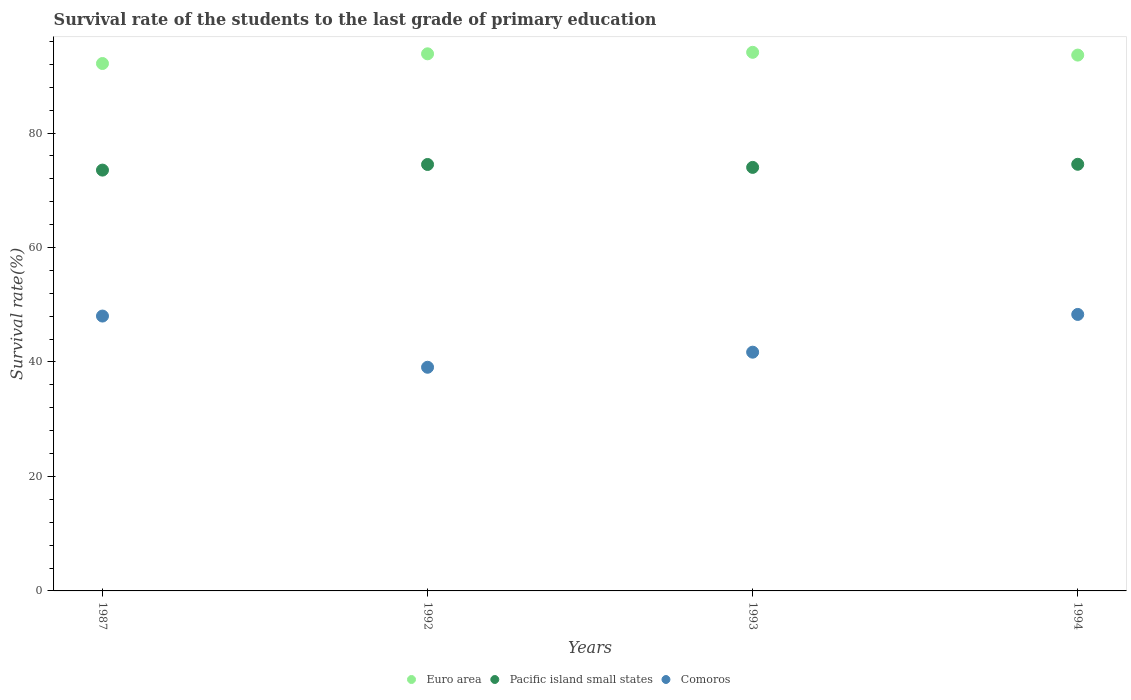How many different coloured dotlines are there?
Your answer should be very brief. 3. Is the number of dotlines equal to the number of legend labels?
Provide a short and direct response. Yes. What is the survival rate of the students in Pacific island small states in 1994?
Give a very brief answer. 74.54. Across all years, what is the maximum survival rate of the students in Pacific island small states?
Offer a very short reply. 74.54. Across all years, what is the minimum survival rate of the students in Euro area?
Offer a terse response. 92.15. In which year was the survival rate of the students in Pacific island small states maximum?
Your response must be concise. 1994. In which year was the survival rate of the students in Pacific island small states minimum?
Your answer should be compact. 1987. What is the total survival rate of the students in Euro area in the graph?
Offer a terse response. 373.71. What is the difference between the survival rate of the students in Pacific island small states in 1993 and that in 1994?
Offer a very short reply. -0.54. What is the difference between the survival rate of the students in Pacific island small states in 1994 and the survival rate of the students in Euro area in 1987?
Offer a terse response. -17.61. What is the average survival rate of the students in Comoros per year?
Offer a terse response. 44.28. In the year 1994, what is the difference between the survival rate of the students in Pacific island small states and survival rate of the students in Euro area?
Make the answer very short. -19.08. What is the ratio of the survival rate of the students in Comoros in 1987 to that in 1994?
Make the answer very short. 0.99. Is the survival rate of the students in Euro area in 1992 less than that in 1993?
Your response must be concise. Yes. Is the difference between the survival rate of the students in Pacific island small states in 1987 and 1994 greater than the difference between the survival rate of the students in Euro area in 1987 and 1994?
Your answer should be very brief. Yes. What is the difference between the highest and the second highest survival rate of the students in Euro area?
Make the answer very short. 0.26. What is the difference between the highest and the lowest survival rate of the students in Pacific island small states?
Provide a succinct answer. 1.02. In how many years, is the survival rate of the students in Euro area greater than the average survival rate of the students in Euro area taken over all years?
Offer a terse response. 3. Is the sum of the survival rate of the students in Euro area in 1987 and 1994 greater than the maximum survival rate of the students in Comoros across all years?
Your answer should be compact. Yes. Is it the case that in every year, the sum of the survival rate of the students in Comoros and survival rate of the students in Euro area  is greater than the survival rate of the students in Pacific island small states?
Offer a terse response. Yes. Is the survival rate of the students in Comoros strictly less than the survival rate of the students in Pacific island small states over the years?
Your answer should be very brief. Yes. How many dotlines are there?
Your response must be concise. 3. What is the difference between two consecutive major ticks on the Y-axis?
Your response must be concise. 20. Are the values on the major ticks of Y-axis written in scientific E-notation?
Offer a very short reply. No. Does the graph contain any zero values?
Make the answer very short. No. How many legend labels are there?
Your response must be concise. 3. What is the title of the graph?
Offer a terse response. Survival rate of the students to the last grade of primary education. What is the label or title of the Y-axis?
Provide a succinct answer. Survival rate(%). What is the Survival rate(%) in Euro area in 1987?
Keep it short and to the point. 92.15. What is the Survival rate(%) of Pacific island small states in 1987?
Your response must be concise. 73.52. What is the Survival rate(%) in Comoros in 1987?
Provide a short and direct response. 48.02. What is the Survival rate(%) in Euro area in 1992?
Your response must be concise. 93.84. What is the Survival rate(%) of Pacific island small states in 1992?
Offer a very short reply. 74.51. What is the Survival rate(%) in Comoros in 1992?
Offer a very short reply. 39.08. What is the Survival rate(%) in Euro area in 1993?
Your answer should be compact. 94.1. What is the Survival rate(%) of Pacific island small states in 1993?
Offer a very short reply. 74. What is the Survival rate(%) of Comoros in 1993?
Ensure brevity in your answer.  41.71. What is the Survival rate(%) of Euro area in 1994?
Your answer should be compact. 93.62. What is the Survival rate(%) of Pacific island small states in 1994?
Provide a short and direct response. 74.54. What is the Survival rate(%) of Comoros in 1994?
Ensure brevity in your answer.  48.31. Across all years, what is the maximum Survival rate(%) in Euro area?
Keep it short and to the point. 94.1. Across all years, what is the maximum Survival rate(%) of Pacific island small states?
Your answer should be compact. 74.54. Across all years, what is the maximum Survival rate(%) in Comoros?
Offer a terse response. 48.31. Across all years, what is the minimum Survival rate(%) of Euro area?
Give a very brief answer. 92.15. Across all years, what is the minimum Survival rate(%) in Pacific island small states?
Offer a terse response. 73.52. Across all years, what is the minimum Survival rate(%) in Comoros?
Offer a very short reply. 39.08. What is the total Survival rate(%) in Euro area in the graph?
Offer a terse response. 373.71. What is the total Survival rate(%) in Pacific island small states in the graph?
Your response must be concise. 296.57. What is the total Survival rate(%) of Comoros in the graph?
Provide a short and direct response. 177.12. What is the difference between the Survival rate(%) of Euro area in 1987 and that in 1992?
Offer a terse response. -1.69. What is the difference between the Survival rate(%) of Pacific island small states in 1987 and that in 1992?
Your answer should be very brief. -0.98. What is the difference between the Survival rate(%) of Comoros in 1987 and that in 1992?
Offer a terse response. 8.95. What is the difference between the Survival rate(%) of Euro area in 1987 and that in 1993?
Give a very brief answer. -1.96. What is the difference between the Survival rate(%) of Pacific island small states in 1987 and that in 1993?
Provide a succinct answer. -0.47. What is the difference between the Survival rate(%) in Comoros in 1987 and that in 1993?
Provide a succinct answer. 6.31. What is the difference between the Survival rate(%) of Euro area in 1987 and that in 1994?
Offer a terse response. -1.47. What is the difference between the Survival rate(%) of Pacific island small states in 1987 and that in 1994?
Give a very brief answer. -1.02. What is the difference between the Survival rate(%) of Comoros in 1987 and that in 1994?
Your answer should be very brief. -0.28. What is the difference between the Survival rate(%) in Euro area in 1992 and that in 1993?
Give a very brief answer. -0.26. What is the difference between the Survival rate(%) in Pacific island small states in 1992 and that in 1993?
Provide a succinct answer. 0.51. What is the difference between the Survival rate(%) of Comoros in 1992 and that in 1993?
Offer a terse response. -2.64. What is the difference between the Survival rate(%) of Euro area in 1992 and that in 1994?
Make the answer very short. 0.22. What is the difference between the Survival rate(%) in Pacific island small states in 1992 and that in 1994?
Your answer should be compact. -0.03. What is the difference between the Survival rate(%) in Comoros in 1992 and that in 1994?
Your answer should be very brief. -9.23. What is the difference between the Survival rate(%) in Euro area in 1993 and that in 1994?
Provide a short and direct response. 0.48. What is the difference between the Survival rate(%) in Pacific island small states in 1993 and that in 1994?
Your response must be concise. -0.54. What is the difference between the Survival rate(%) of Comoros in 1993 and that in 1994?
Ensure brevity in your answer.  -6.59. What is the difference between the Survival rate(%) of Euro area in 1987 and the Survival rate(%) of Pacific island small states in 1992?
Offer a very short reply. 17.64. What is the difference between the Survival rate(%) of Euro area in 1987 and the Survival rate(%) of Comoros in 1992?
Make the answer very short. 53.07. What is the difference between the Survival rate(%) of Pacific island small states in 1987 and the Survival rate(%) of Comoros in 1992?
Give a very brief answer. 34.45. What is the difference between the Survival rate(%) of Euro area in 1987 and the Survival rate(%) of Pacific island small states in 1993?
Ensure brevity in your answer.  18.15. What is the difference between the Survival rate(%) of Euro area in 1987 and the Survival rate(%) of Comoros in 1993?
Your answer should be compact. 50.44. What is the difference between the Survival rate(%) in Pacific island small states in 1987 and the Survival rate(%) in Comoros in 1993?
Provide a short and direct response. 31.81. What is the difference between the Survival rate(%) of Euro area in 1987 and the Survival rate(%) of Pacific island small states in 1994?
Offer a terse response. 17.61. What is the difference between the Survival rate(%) of Euro area in 1987 and the Survival rate(%) of Comoros in 1994?
Keep it short and to the point. 43.84. What is the difference between the Survival rate(%) of Pacific island small states in 1987 and the Survival rate(%) of Comoros in 1994?
Provide a short and direct response. 25.22. What is the difference between the Survival rate(%) of Euro area in 1992 and the Survival rate(%) of Pacific island small states in 1993?
Offer a terse response. 19.84. What is the difference between the Survival rate(%) of Euro area in 1992 and the Survival rate(%) of Comoros in 1993?
Your response must be concise. 52.13. What is the difference between the Survival rate(%) of Pacific island small states in 1992 and the Survival rate(%) of Comoros in 1993?
Your response must be concise. 32.79. What is the difference between the Survival rate(%) in Euro area in 1992 and the Survival rate(%) in Pacific island small states in 1994?
Your answer should be very brief. 19.3. What is the difference between the Survival rate(%) of Euro area in 1992 and the Survival rate(%) of Comoros in 1994?
Your answer should be very brief. 45.53. What is the difference between the Survival rate(%) in Pacific island small states in 1992 and the Survival rate(%) in Comoros in 1994?
Keep it short and to the point. 26.2. What is the difference between the Survival rate(%) in Euro area in 1993 and the Survival rate(%) in Pacific island small states in 1994?
Your answer should be compact. 19.56. What is the difference between the Survival rate(%) in Euro area in 1993 and the Survival rate(%) in Comoros in 1994?
Make the answer very short. 45.8. What is the difference between the Survival rate(%) of Pacific island small states in 1993 and the Survival rate(%) of Comoros in 1994?
Provide a succinct answer. 25.69. What is the average Survival rate(%) in Euro area per year?
Your answer should be compact. 93.43. What is the average Survival rate(%) of Pacific island small states per year?
Provide a succinct answer. 74.14. What is the average Survival rate(%) of Comoros per year?
Provide a short and direct response. 44.28. In the year 1987, what is the difference between the Survival rate(%) in Euro area and Survival rate(%) in Pacific island small states?
Make the answer very short. 18.62. In the year 1987, what is the difference between the Survival rate(%) in Euro area and Survival rate(%) in Comoros?
Provide a short and direct response. 44.12. In the year 1987, what is the difference between the Survival rate(%) of Pacific island small states and Survival rate(%) of Comoros?
Provide a succinct answer. 25.5. In the year 1992, what is the difference between the Survival rate(%) of Euro area and Survival rate(%) of Pacific island small states?
Give a very brief answer. 19.33. In the year 1992, what is the difference between the Survival rate(%) of Euro area and Survival rate(%) of Comoros?
Keep it short and to the point. 54.76. In the year 1992, what is the difference between the Survival rate(%) of Pacific island small states and Survival rate(%) of Comoros?
Offer a terse response. 35.43. In the year 1993, what is the difference between the Survival rate(%) in Euro area and Survival rate(%) in Pacific island small states?
Offer a terse response. 20.1. In the year 1993, what is the difference between the Survival rate(%) in Euro area and Survival rate(%) in Comoros?
Your answer should be compact. 52.39. In the year 1993, what is the difference between the Survival rate(%) in Pacific island small states and Survival rate(%) in Comoros?
Offer a terse response. 32.29. In the year 1994, what is the difference between the Survival rate(%) in Euro area and Survival rate(%) in Pacific island small states?
Your response must be concise. 19.08. In the year 1994, what is the difference between the Survival rate(%) of Euro area and Survival rate(%) of Comoros?
Make the answer very short. 45.31. In the year 1994, what is the difference between the Survival rate(%) of Pacific island small states and Survival rate(%) of Comoros?
Your answer should be very brief. 26.23. What is the ratio of the Survival rate(%) in Comoros in 1987 to that in 1992?
Give a very brief answer. 1.23. What is the ratio of the Survival rate(%) of Euro area in 1987 to that in 1993?
Your answer should be very brief. 0.98. What is the ratio of the Survival rate(%) in Comoros in 1987 to that in 1993?
Give a very brief answer. 1.15. What is the ratio of the Survival rate(%) in Euro area in 1987 to that in 1994?
Your answer should be compact. 0.98. What is the ratio of the Survival rate(%) of Pacific island small states in 1987 to that in 1994?
Your response must be concise. 0.99. What is the ratio of the Survival rate(%) of Euro area in 1992 to that in 1993?
Offer a very short reply. 1. What is the ratio of the Survival rate(%) in Comoros in 1992 to that in 1993?
Provide a succinct answer. 0.94. What is the ratio of the Survival rate(%) of Euro area in 1992 to that in 1994?
Provide a short and direct response. 1. What is the ratio of the Survival rate(%) of Pacific island small states in 1992 to that in 1994?
Offer a terse response. 1. What is the ratio of the Survival rate(%) in Comoros in 1992 to that in 1994?
Keep it short and to the point. 0.81. What is the ratio of the Survival rate(%) of Euro area in 1993 to that in 1994?
Provide a succinct answer. 1.01. What is the ratio of the Survival rate(%) in Comoros in 1993 to that in 1994?
Provide a short and direct response. 0.86. What is the difference between the highest and the second highest Survival rate(%) of Euro area?
Your response must be concise. 0.26. What is the difference between the highest and the second highest Survival rate(%) in Pacific island small states?
Your response must be concise. 0.03. What is the difference between the highest and the second highest Survival rate(%) in Comoros?
Your response must be concise. 0.28. What is the difference between the highest and the lowest Survival rate(%) in Euro area?
Your answer should be compact. 1.96. What is the difference between the highest and the lowest Survival rate(%) in Pacific island small states?
Offer a very short reply. 1.02. What is the difference between the highest and the lowest Survival rate(%) of Comoros?
Your response must be concise. 9.23. 